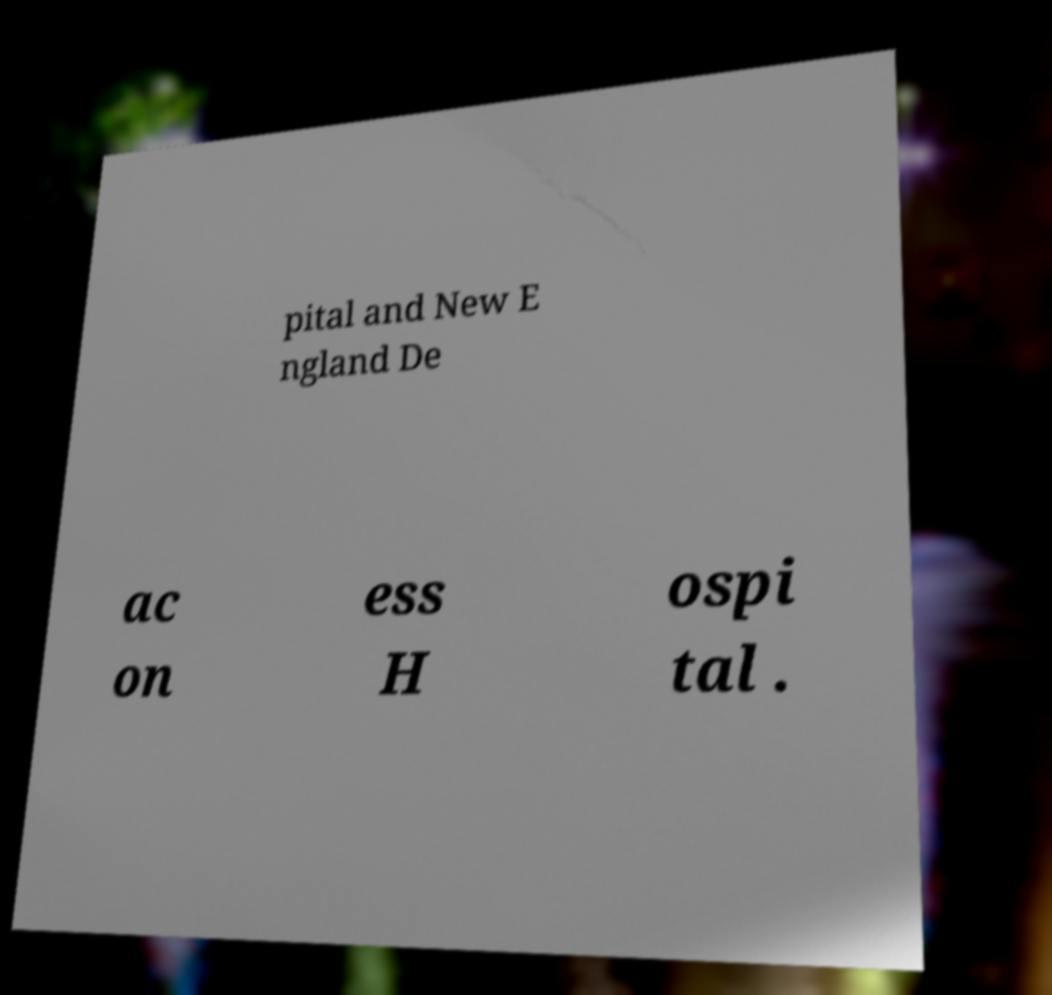What messages or text are displayed in this image? I need them in a readable, typed format. pital and New E ngland De ac on ess H ospi tal . 